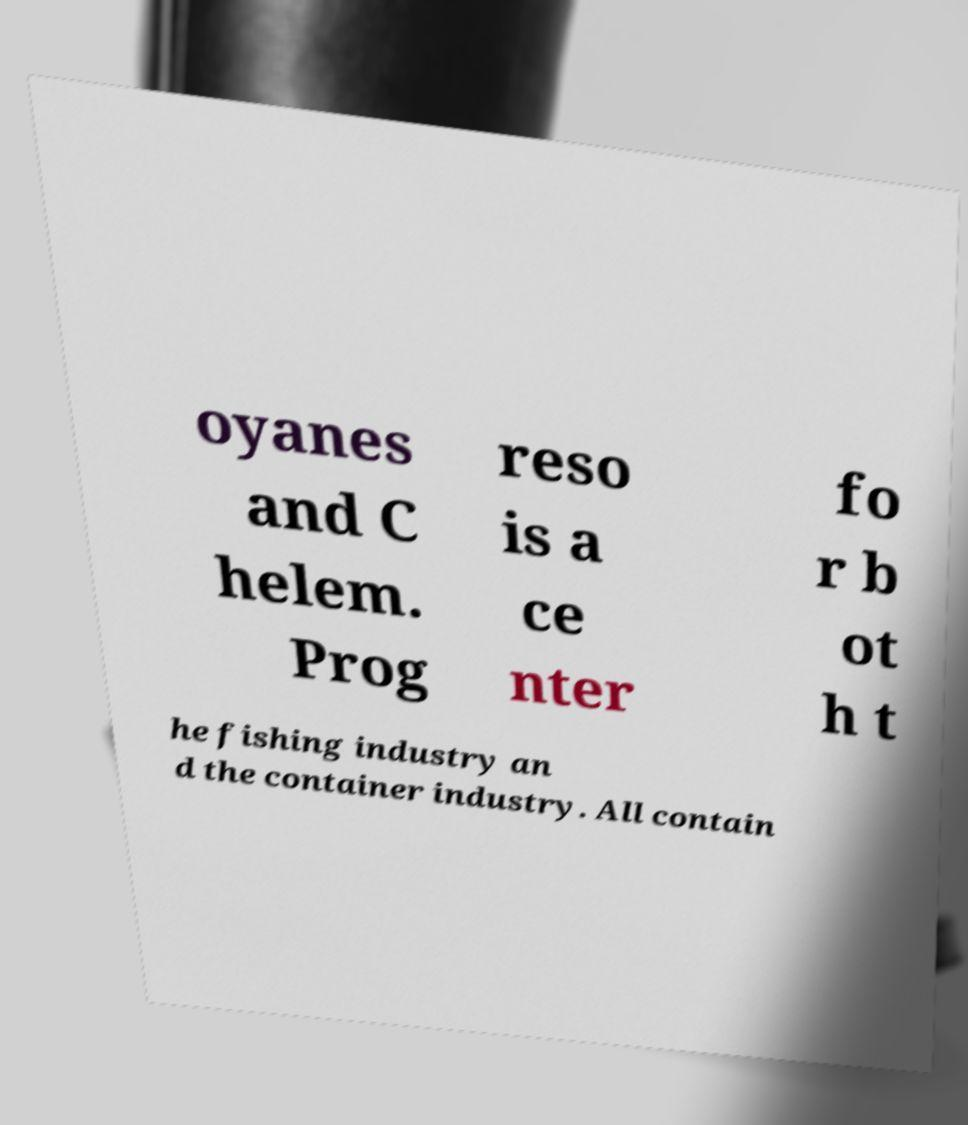Please identify and transcribe the text found in this image. oyanes and C helem. Prog reso is a ce nter fo r b ot h t he fishing industry an d the container industry. All contain 